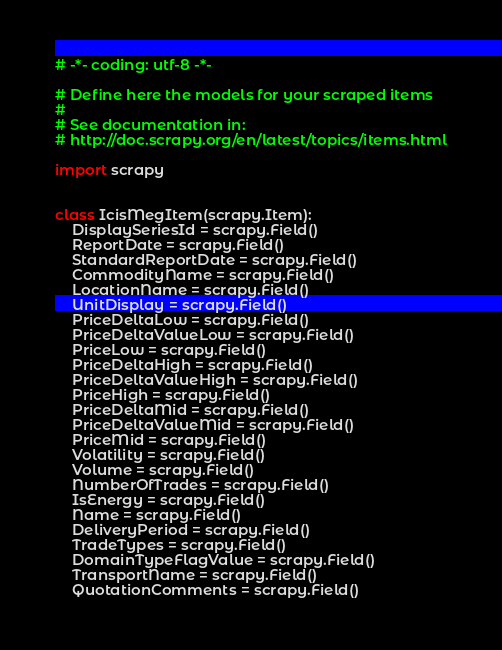Convert code to text. <code><loc_0><loc_0><loc_500><loc_500><_Python_># -*- coding: utf-8 -*-

# Define here the models for your scraped items
#
# See documentation in:
# http://doc.scrapy.org/en/latest/topics/items.html

import scrapy


class IcisMegItem(scrapy.Item):
    DisplaySeriesId = scrapy.Field()
    ReportDate = scrapy.Field()
    StandardReportDate = scrapy.Field()
    CommodityName = scrapy.Field()
    LocationName = scrapy.Field()
    UnitDisplay = scrapy.Field()
    PriceDeltaLow = scrapy.Field()
    PriceDeltaValueLow = scrapy.Field()
    PriceLow = scrapy.Field()
    PriceDeltaHigh = scrapy.Field()
    PriceDeltaValueHigh = scrapy.Field()
    PriceHigh = scrapy.Field()
    PriceDeltaMid = scrapy.Field()
    PriceDeltaValueMid = scrapy.Field()
    PriceMid = scrapy.Field()
    Volatility = scrapy.Field()
    Volume = scrapy.Field()
    NumberOfTrades = scrapy.Field()
    IsEnergy = scrapy.Field()
    Name = scrapy.Field()
    DeliveryPeriod = scrapy.Field()
    TradeTypes = scrapy.Field()
    DomainTypeFlagValue = scrapy.Field()
    TransportName = scrapy.Field()
    QuotationComments = scrapy.Field()
</code> 